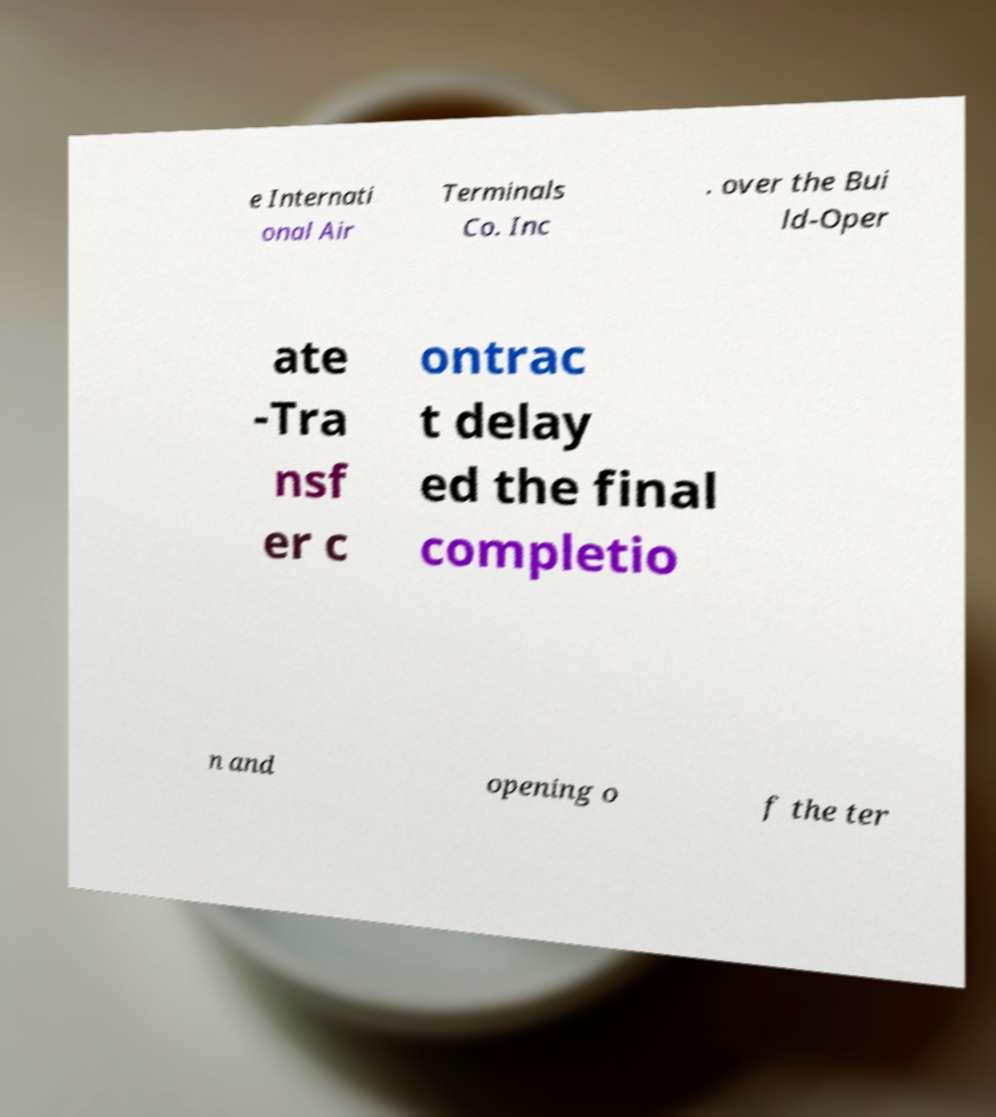What messages or text are displayed in this image? I need them in a readable, typed format. e Internati onal Air Terminals Co. Inc . over the Bui ld-Oper ate -Tra nsf er c ontrac t delay ed the final completio n and opening o f the ter 